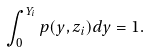<formula> <loc_0><loc_0><loc_500><loc_500>\int ^ { Y _ { i } } _ { 0 } p ( y , z _ { i } ) d y = 1 .</formula> 